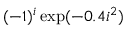Convert formula to latex. <formula><loc_0><loc_0><loc_500><loc_500>( - 1 ) ^ { i } \exp ( - 0 . 4 i ^ { 2 } )</formula> 